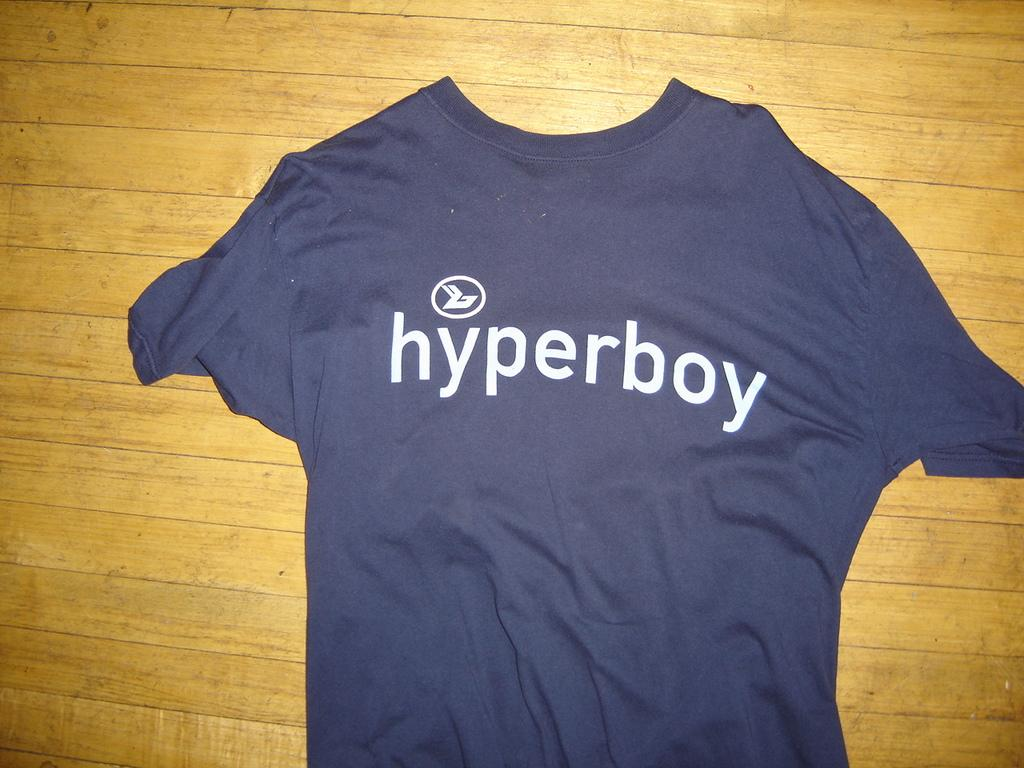<image>
Render a clear and concise summary of the photo. A blue shirt says hyperboy in white letters. 